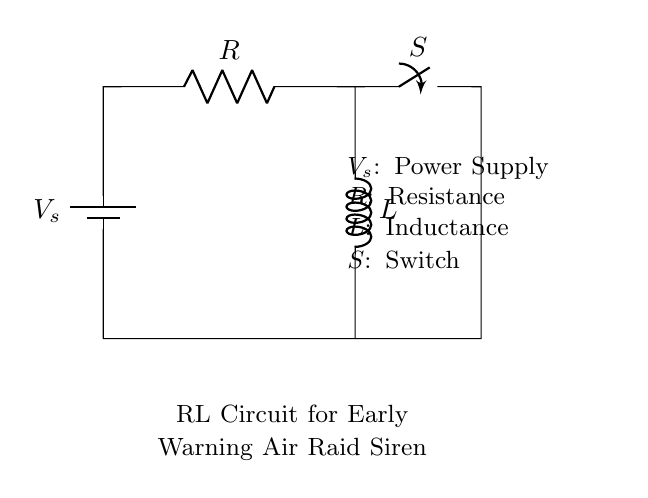What type of circuit is shown? The circuit comprises a resistor and an inductor connected in series with a power supply and a switch. This defines it as an RL circuit.
Answer: RL circuit What does the switch do in this circuit? The switch controls the flow of current in the circuit. When the switch is closed, it allows current to pass through the resistor and inductor; when open, it stops current flow.
Answer: Controls current flow What is the purpose of the inductor in this circuit? The inductor stores energy in a magnetic field when current flows through it, causing a delay in current rise and affecting circuit timing, crucial for triggering the siren.
Answer: Stores energy What happens when the switch is closed? Closing the switch enables current to flow, allowing the inductor to charge and gradually increasing the current until it reaches its maximum value based on the resistance and inductance.
Answer: Current increases What will be the voltage across the inductor immediately after closing the switch? Immediately after closing the switch, the voltage across the inductor is equal to the source voltage. This is due to the inductor initially opposing changes in current.
Answer: Source voltage How does resistance affect the current in this RL circuit? Resistance limits the amount of current that can flow through the circuit. Higher resistance results in lower current for the same voltage, affecting the charging time of the inductor.
Answer: Limits current 